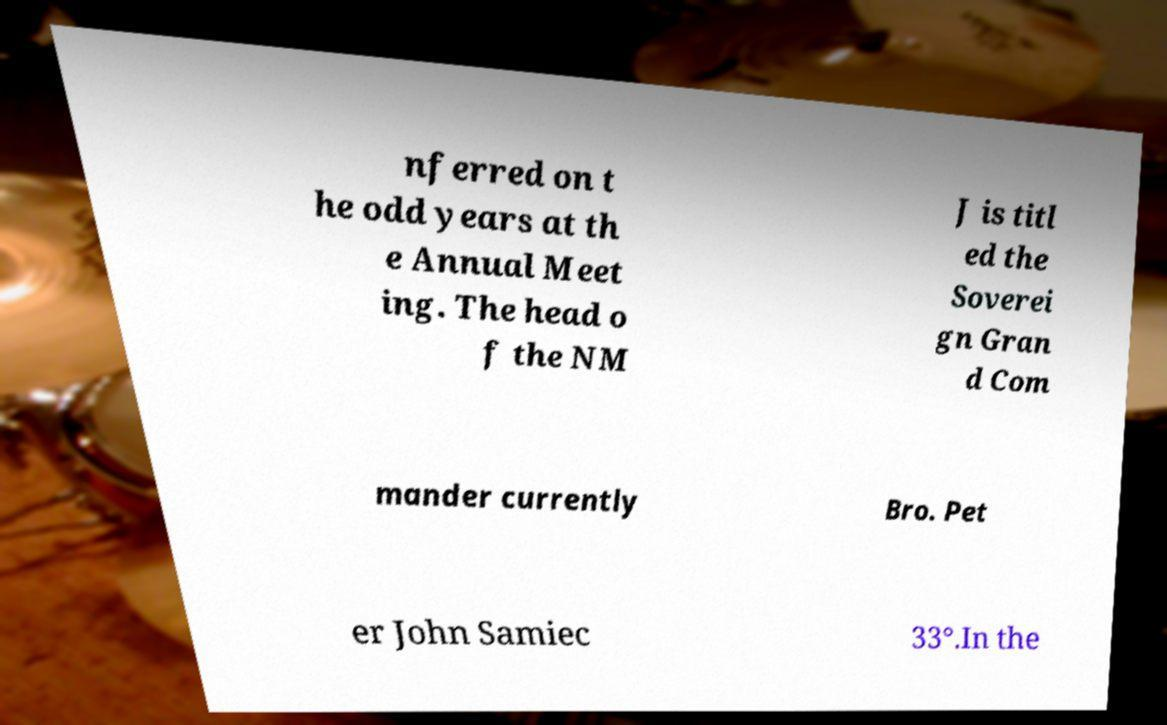I need the written content from this picture converted into text. Can you do that? nferred on t he odd years at th e Annual Meet ing. The head o f the NM J is titl ed the Soverei gn Gran d Com mander currently Bro. Pet er John Samiec 33°.In the 